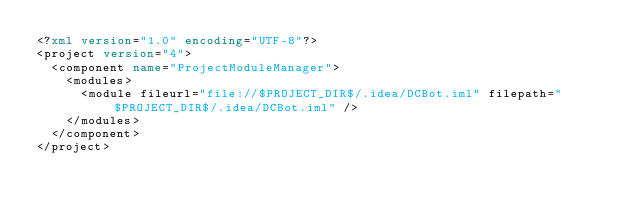Convert code to text. <code><loc_0><loc_0><loc_500><loc_500><_XML_><?xml version="1.0" encoding="UTF-8"?>
<project version="4">
  <component name="ProjectModuleManager">
    <modules>
      <module fileurl="file://$PROJECT_DIR$/.idea/DCBot.iml" filepath="$PROJECT_DIR$/.idea/DCBot.iml" />
    </modules>
  </component>
</project></code> 